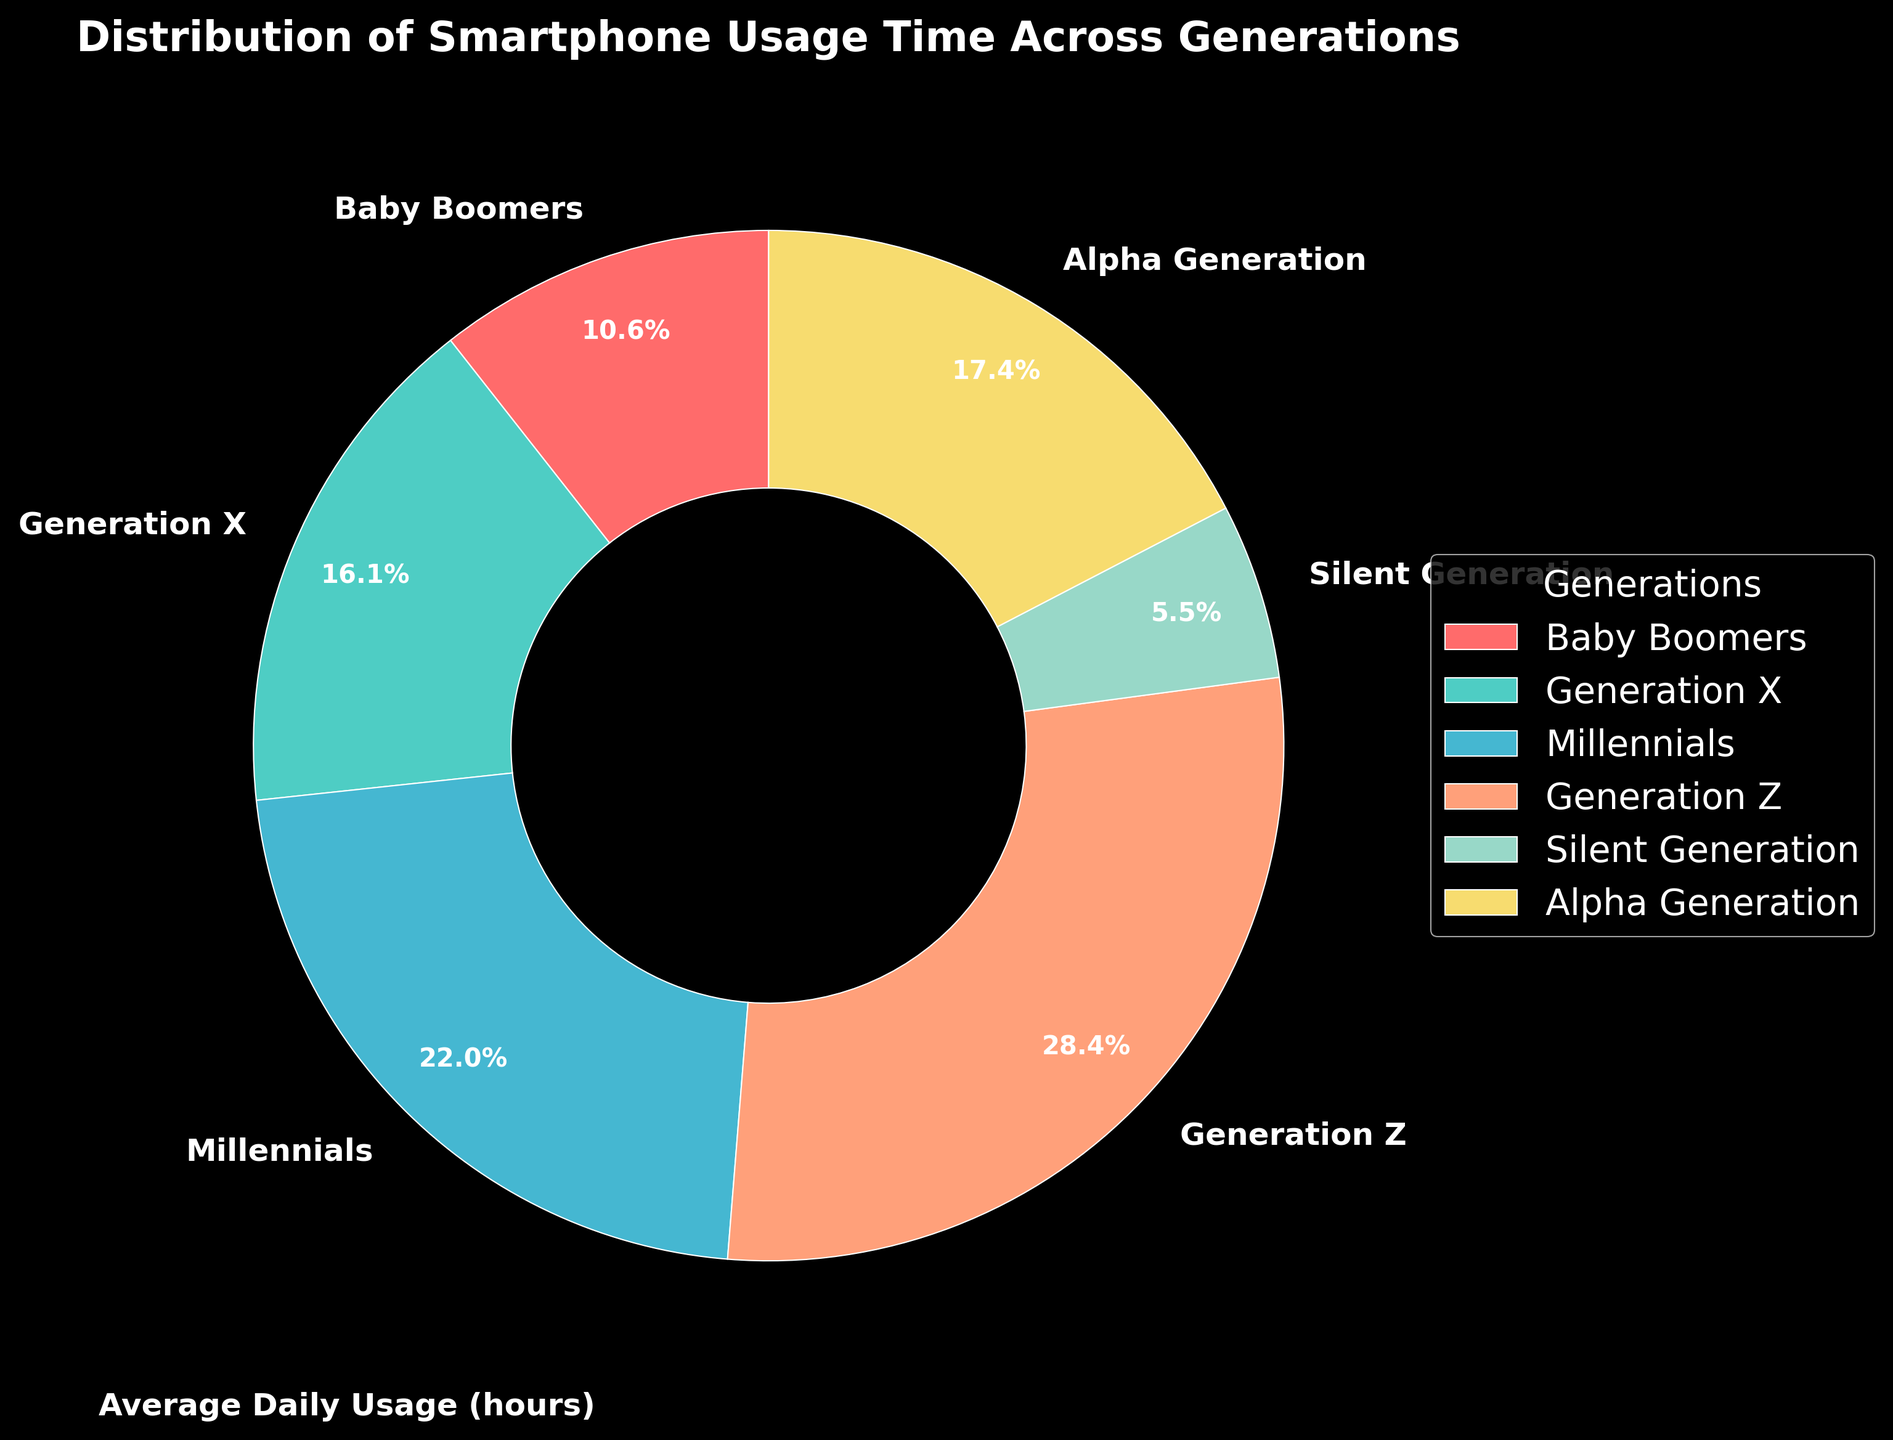Which generation has the highest average daily smartphone usage? From the pie chart, Generation Z has the largest segment, clearly indicating the highest usage.
Answer: Generation Z What is the difference in average daily usage between Millennials and Baby Boomers? Millennials average 5.2 hours, and Baby Boomers average 2.5 hours. The difference is 5.2 - 2.5 = 2.7 hours.
Answer: 2.7 hours How does Generation X's smartphone usage compare to Alpha Generation? Generation X's usage (3.8 hours) is less than Alpha Generation's usage (4.1 hours).
Answer: Generation X's usage is less Which generation shows the lowest smartphone usage? The segment representing Silent Generation is the smallest, indicating the lowest usage.
Answer: Silent Generation What is the combined average daily usage of Generation X and Millennials? Generation X's usage is 3.8 hours and Millennials' is 5.2 hours. The combined usage is 3.8 + 5.2 = 9.0 hours.
Answer: 9.0 hours If we consider Baby Boomers and the Silent Generation together, do they still have lower average daily usage than Generation Z? Baby Boomers' usage is 2.5 hours, and Silent Generation's is 1.3 hours. Combined, they use 2.5 + 1.3 = 3.8 hours, which is less than Generation Z's 6.7 hours.
Answer: Yes, they have lower usage Which color corresponds to Generation X in the figure? Generation X's segment is denoted by a light green color.
Answer: Light green What is the total average daily smartphone usage time represented by all generations in the chart? Adding the averages: 2.5 + 3.8 + 5.2 + 6.7 + 1.3 + 4.1 = 23.6 hours.
Answer: 23.6 hours Which generations have an average daily usage time greater than 4 hours? The segments representing Millennials (5.2 hours), Generation Z (6.7 hours), and Alpha Generation (4.1 hours) are all above 4 hours.
Answer: Millennials, Generation Z, Alpha Generation 